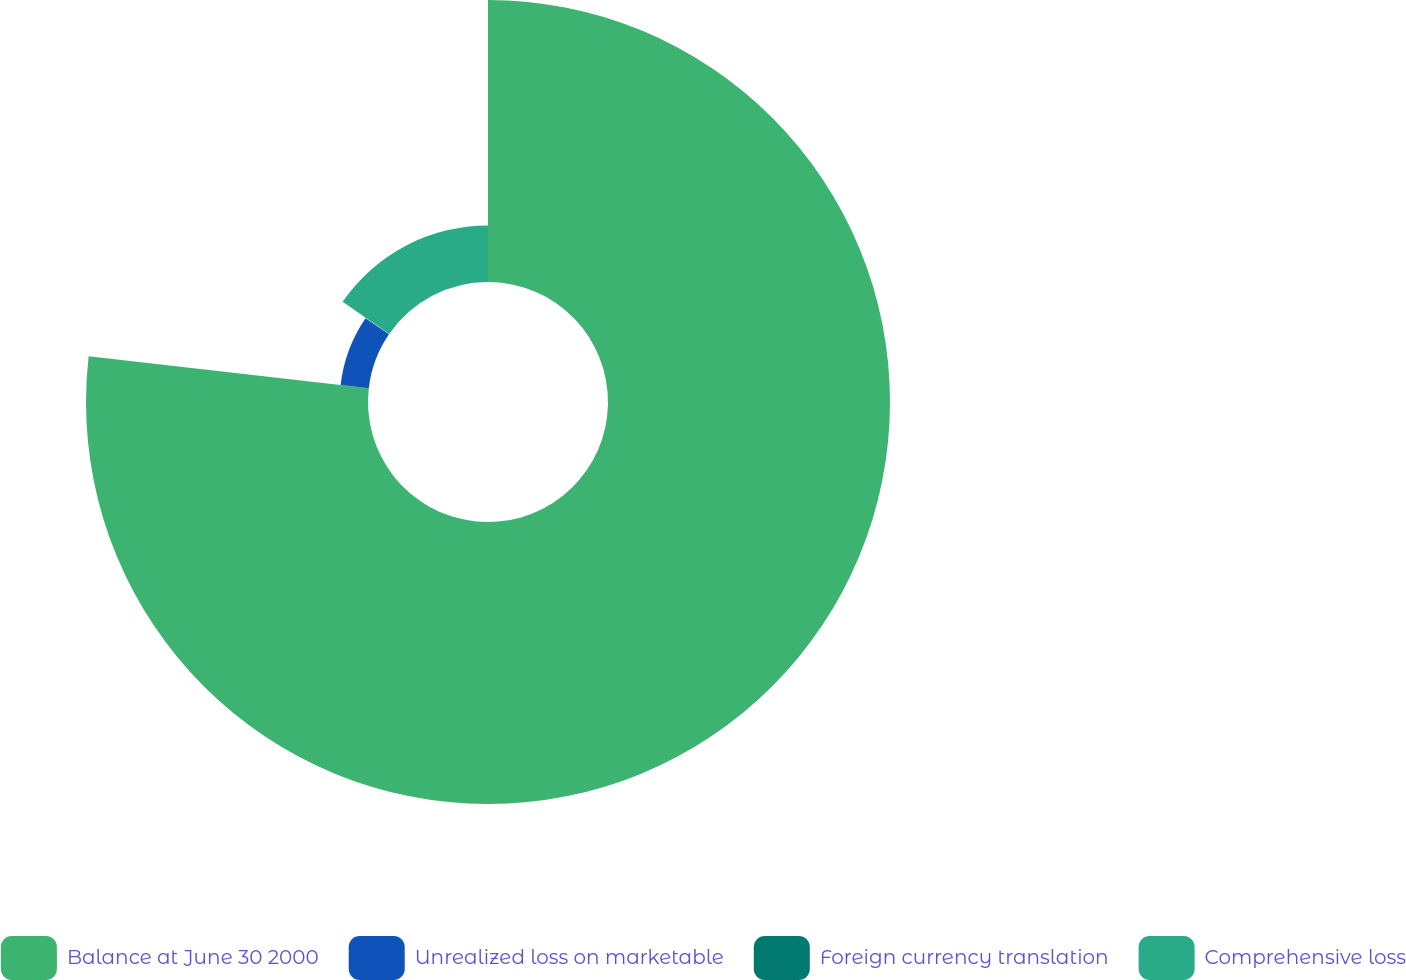Convert chart. <chart><loc_0><loc_0><loc_500><loc_500><pie_chart><fcel>Balance at June 30 2000<fcel>Unrealized loss on marketable<fcel>Foreign currency translation<fcel>Comprehensive loss<nl><fcel>76.81%<fcel>7.73%<fcel>0.05%<fcel>15.4%<nl></chart> 